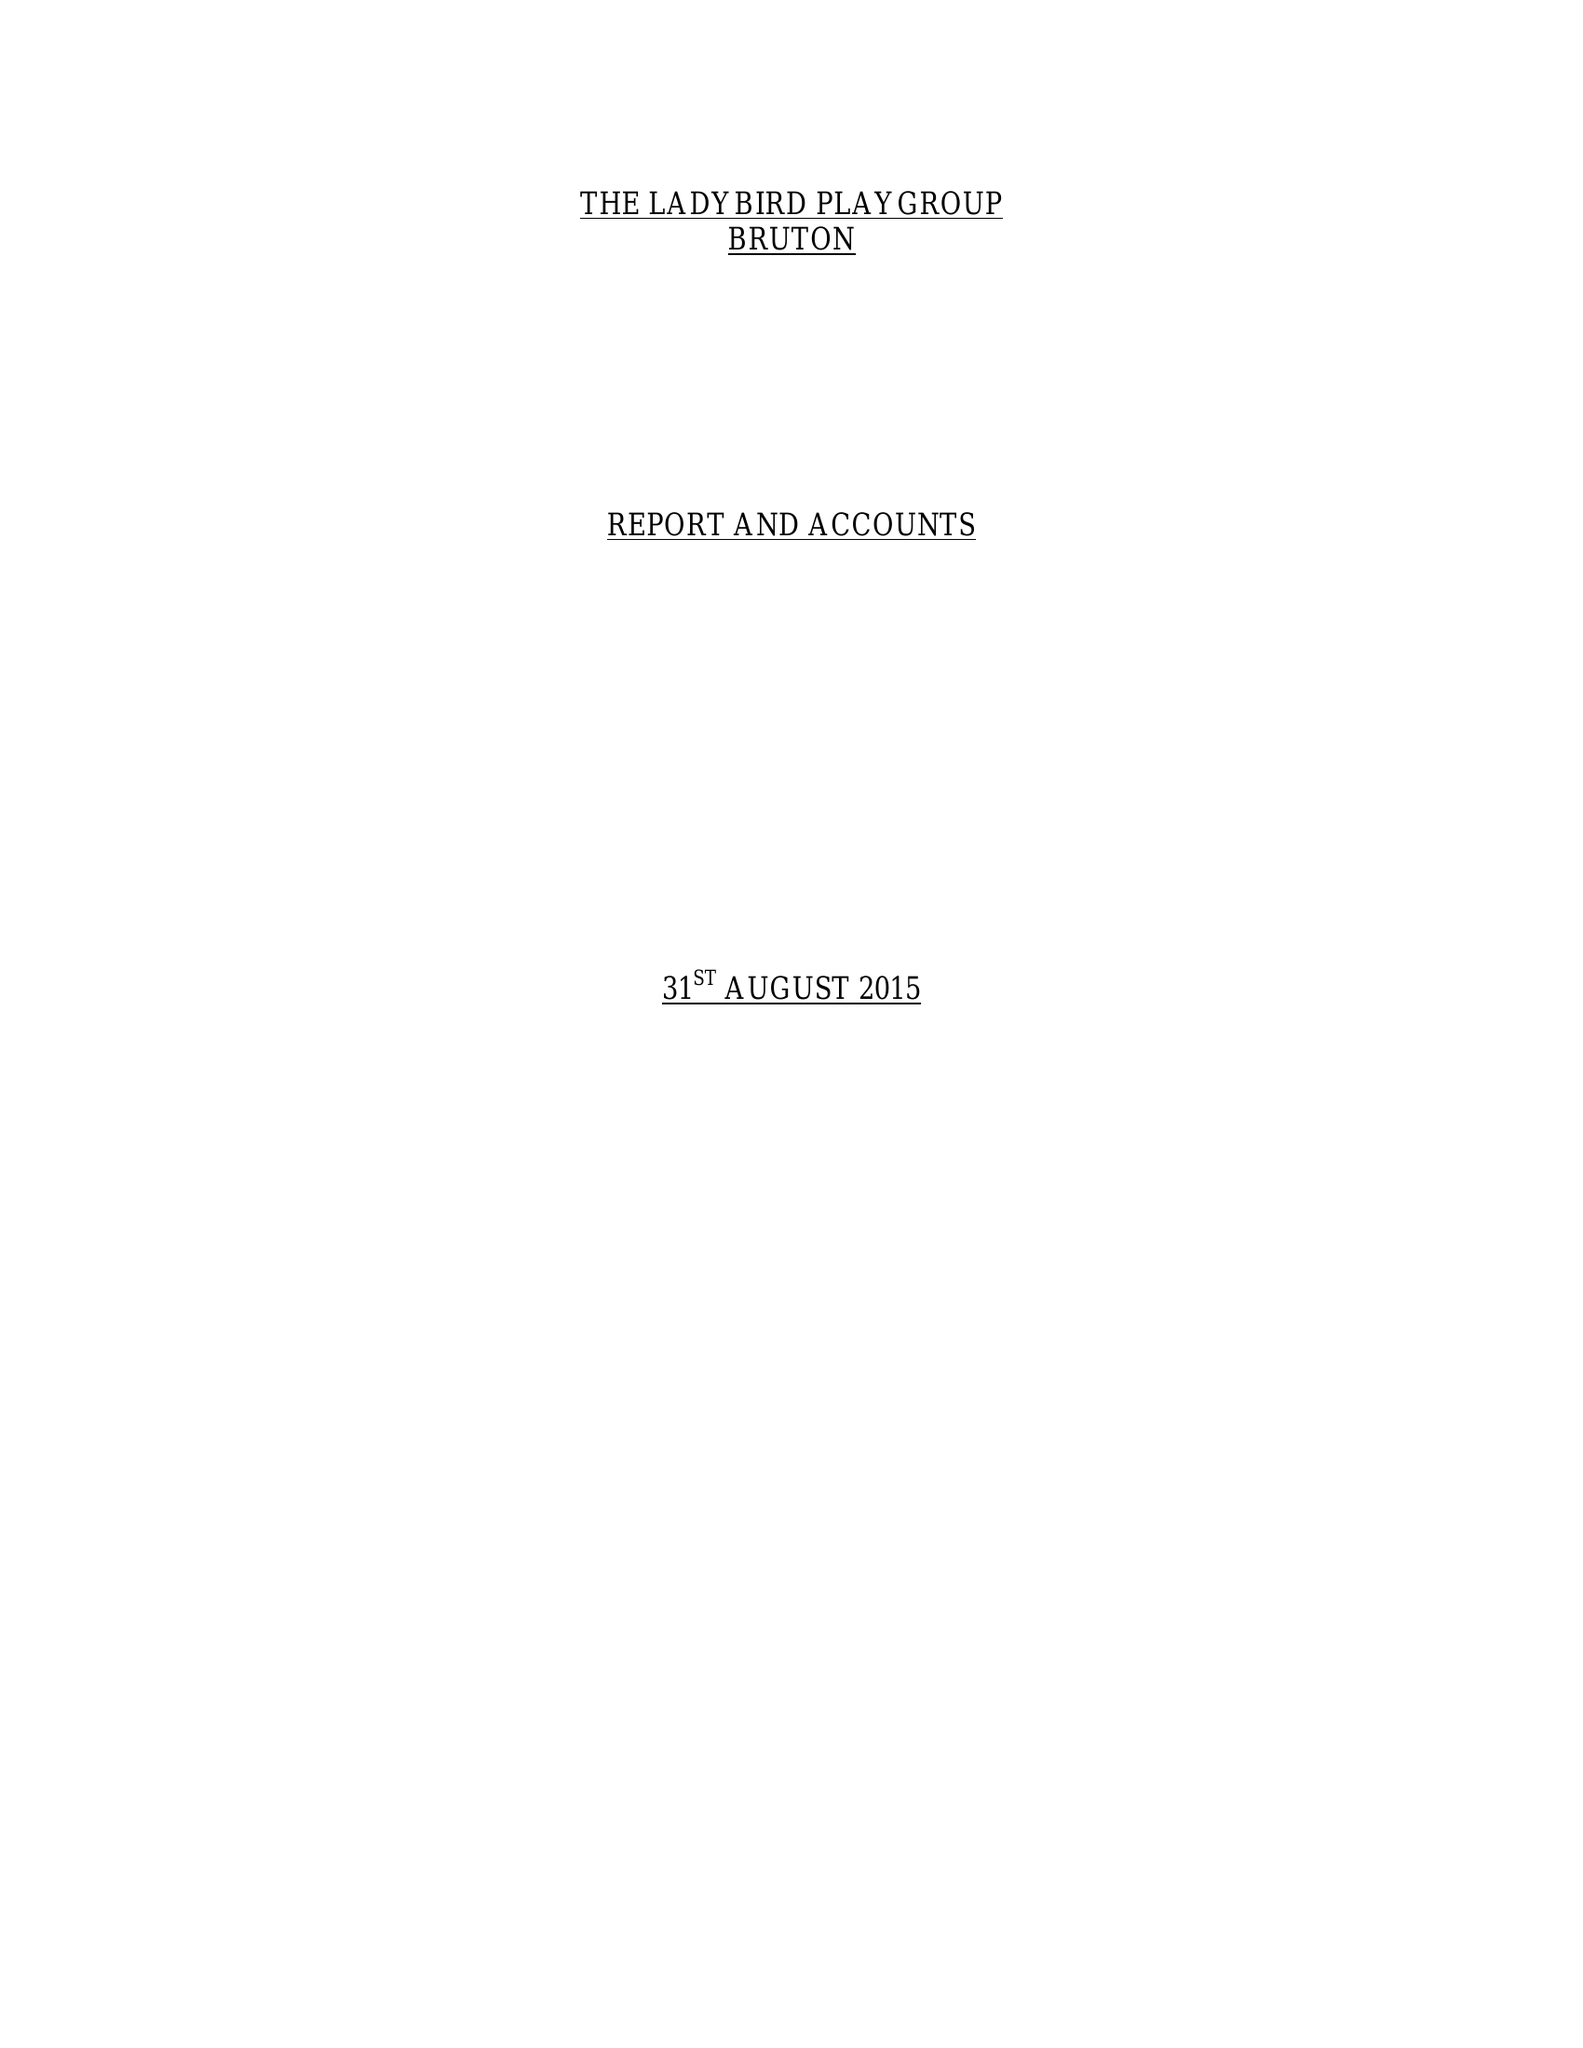What is the value for the charity_number?
Answer the question using a single word or phrase. 1038847 